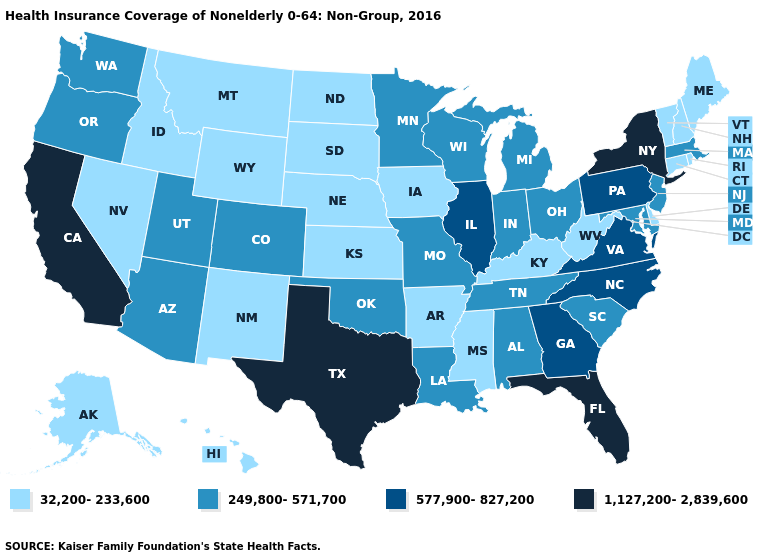How many symbols are there in the legend?
Write a very short answer. 4. What is the value of Georgia?
Give a very brief answer. 577,900-827,200. Name the states that have a value in the range 1,127,200-2,839,600?
Give a very brief answer. California, Florida, New York, Texas. Name the states that have a value in the range 1,127,200-2,839,600?
Short answer required. California, Florida, New York, Texas. What is the highest value in the USA?
Short answer required. 1,127,200-2,839,600. How many symbols are there in the legend?
Write a very short answer. 4. Name the states that have a value in the range 1,127,200-2,839,600?
Answer briefly. California, Florida, New York, Texas. What is the value of Louisiana?
Be succinct. 249,800-571,700. What is the lowest value in states that border Florida?
Concise answer only. 249,800-571,700. Among the states that border Florida , which have the lowest value?
Write a very short answer. Alabama. Name the states that have a value in the range 249,800-571,700?
Quick response, please. Alabama, Arizona, Colorado, Indiana, Louisiana, Maryland, Massachusetts, Michigan, Minnesota, Missouri, New Jersey, Ohio, Oklahoma, Oregon, South Carolina, Tennessee, Utah, Washington, Wisconsin. Name the states that have a value in the range 577,900-827,200?
Give a very brief answer. Georgia, Illinois, North Carolina, Pennsylvania, Virginia. What is the value of Wyoming?
Be succinct. 32,200-233,600. What is the value of Pennsylvania?
Write a very short answer. 577,900-827,200. 